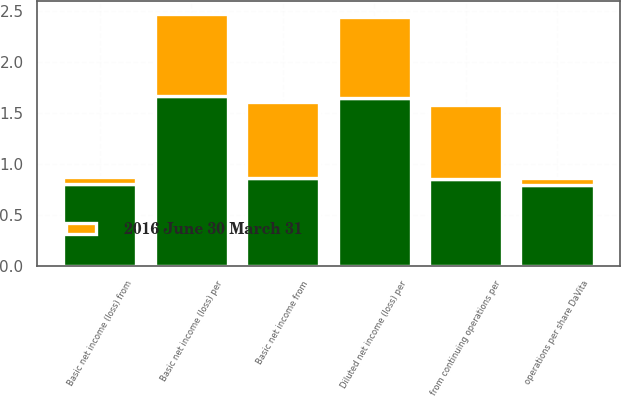Convert chart. <chart><loc_0><loc_0><loc_500><loc_500><stacked_bar_chart><ecel><fcel>Basic net income from<fcel>Basic net income (loss) from<fcel>Basic net income (loss) per<fcel>from continuing operations per<fcel>operations per share DaVita<fcel>Diluted net income (loss) per<nl><fcel>nan<fcel>0.86<fcel>0.8<fcel>1.66<fcel>0.85<fcel>0.79<fcel>1.64<nl><fcel>2016 June 30 March 31<fcel>0.74<fcel>0.07<fcel>0.81<fcel>0.73<fcel>0.07<fcel>0.8<nl></chart> 